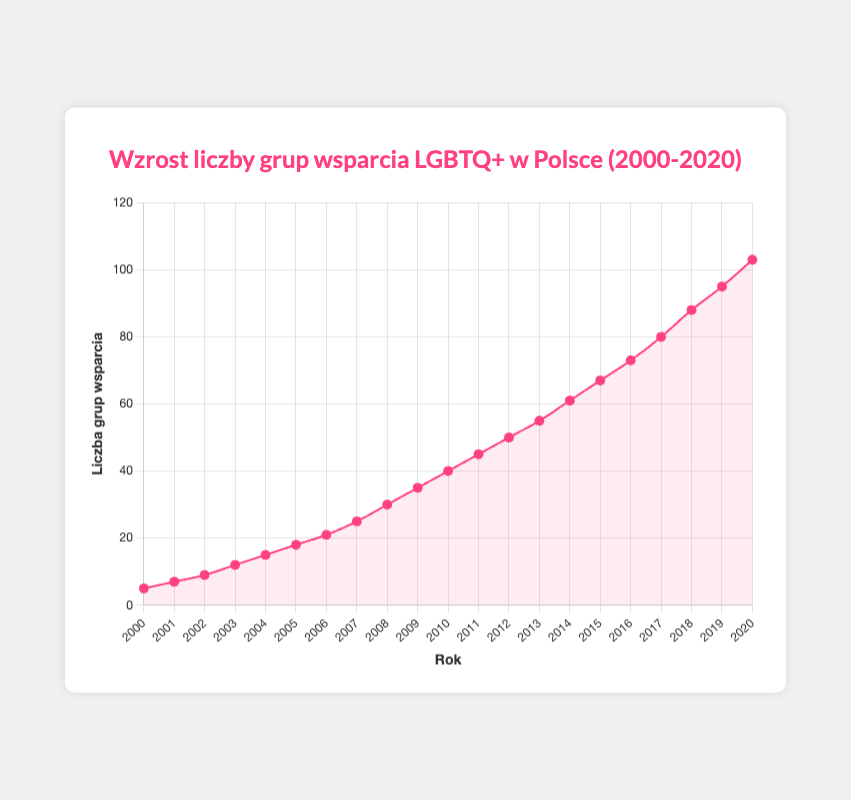Which year saw the highest number of LGBTQ+ support groups in Poland? The visual plot shows that each year has a corresponding number of LGBTQ+ support groups marked. From 2000 to 2020, the year with the highest value is 2020.
Answer: 2020 By how many did the number of LGBTQ+ support groups increase from 2000 to 2010? In 2000, there were 5 support groups and in 2010, there were 40. Subtracting the 2000 value from the 2010 value, we get 40 - 5 = 35.
Answer: 35 What is the average number of LGBTQ+ support groups in the years 2015, 2016, and 2017? The support groups in these years are 67, 73, and 80, respectively. Summing them gives 67 + 73 + 80 = 220, and dividing by 3 gives 220 / 3 ≈ 73.33.
Answer: Approximately 73.33 How does the growth rate between 2005 and 2010 compare to the growth rate between 2015 and 2020? Between 2005 and 2010, the support groups grew from 18 to 40, which is an increase of 22 over 5 years. Between 2015 and 2020, they grew from 67 to 103, an increase of 36 over 5 years. The growth rate from 2015 to 2020 was higher.
Answer: Higher from 2015 to 2020 Which years had the same rate of increase in LGBTQ+ support groups compared to the previous year? To find years with the same rate of increase, we look for consecutive years where the difference in the number of groups is equal. From the data, 2014 to 2015 and 2018 to 2019 both show an increment of 7 groups per year (2014: 61, 2015: 67, 2018: 88, 2019: 95).
Answer: 2014-2015 and 2018-2019 During which 5-year period was the increase in LGBTQ+ support groups the highest? Compare the number of groups developed within each 5-year period. From 2015 (67) to 2020 (103), the increase is 103 - 67 = 36. No other 5-year span has a higher increase.
Answer: 2015-2020 How many more LGBTQ+ support groups were there in 2020 compared to 2010? There were 40 groups in 2010 and 103 in 2020. Subtracting 40 from 103 gives 103 - 40 = 63.
Answer: 63 In which year did the number of LGBTQ+ support groups first reach double the amount of 2000? In 2000, there were 5 support groups. Doubling this gives 10. The year 2002 has 12 groups, which is more than double 5.
Answer: 2002 Describe the trend in the number of LGBTQ+ support groups from 2000 to 2020. Visually inspecting the plot, the number of support groups increases consistently over time, with a notable upward trend throughout the entire period.
Answer: Consistent increase What's the difference in the number of LGBTQ+ support groups between the years with the highest and lowest values? The year with the highest number (2020) has 103 groups, and the year with the lowest (2000) has 5. Subtracting these gives 103 - 5 = 98.
Answer: 98 